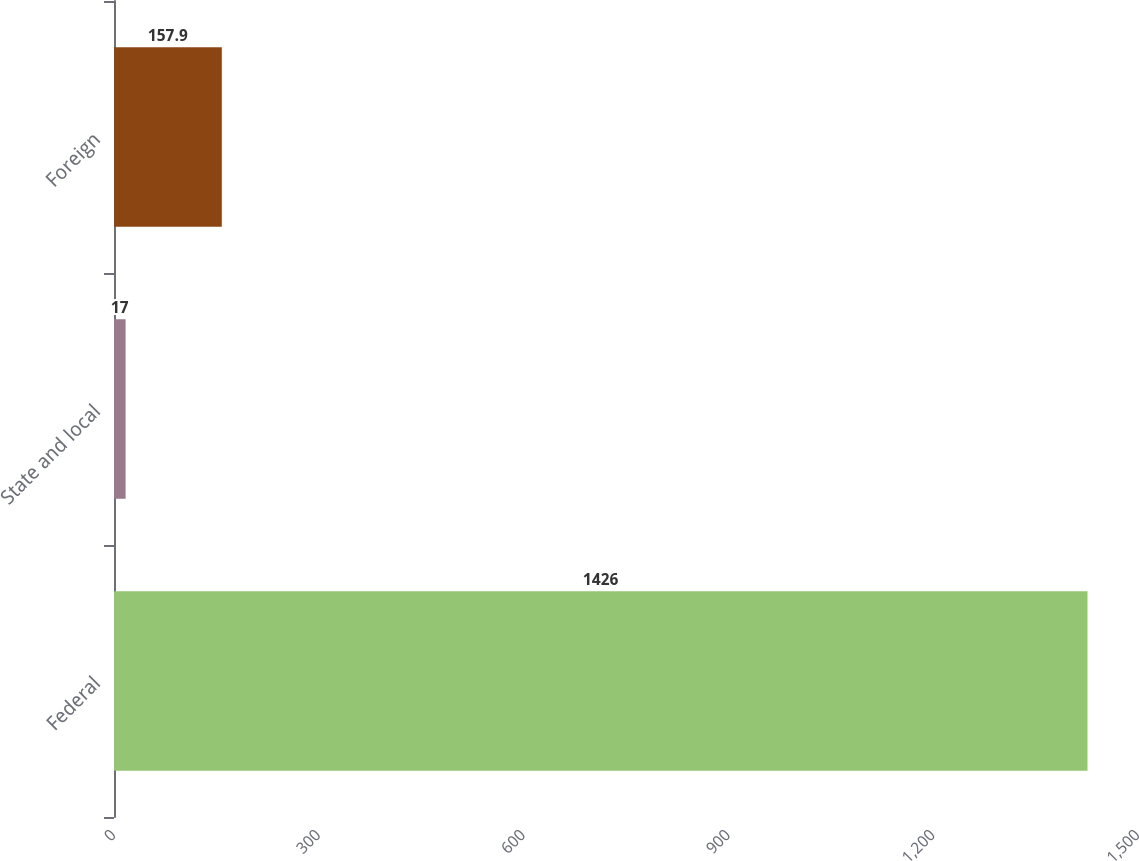Convert chart. <chart><loc_0><loc_0><loc_500><loc_500><bar_chart><fcel>Federal<fcel>State and local<fcel>Foreign<nl><fcel>1426<fcel>17<fcel>157.9<nl></chart> 